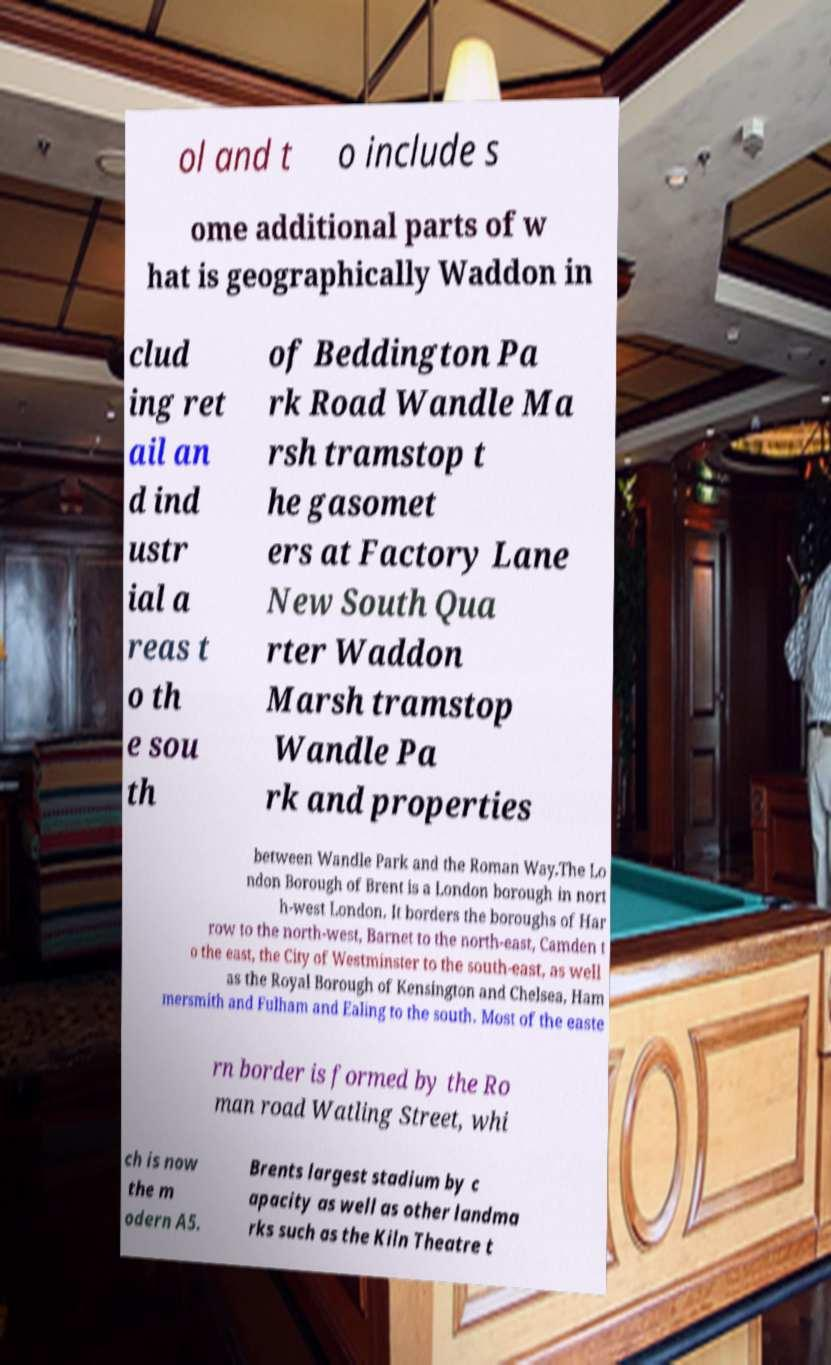There's text embedded in this image that I need extracted. Can you transcribe it verbatim? ol and t o include s ome additional parts of w hat is geographically Waddon in clud ing ret ail an d ind ustr ial a reas t o th e sou th of Beddington Pa rk Road Wandle Ma rsh tramstop t he gasomet ers at Factory Lane New South Qua rter Waddon Marsh tramstop Wandle Pa rk and properties between Wandle Park and the Roman Way.The Lo ndon Borough of Brent is a London borough in nort h-west London. It borders the boroughs of Har row to the north-west, Barnet to the north-east, Camden t o the east, the City of Westminster to the south-east, as well as the Royal Borough of Kensington and Chelsea, Ham mersmith and Fulham and Ealing to the south. Most of the easte rn border is formed by the Ro man road Watling Street, whi ch is now the m odern A5. Brents largest stadium by c apacity as well as other landma rks such as the Kiln Theatre t 